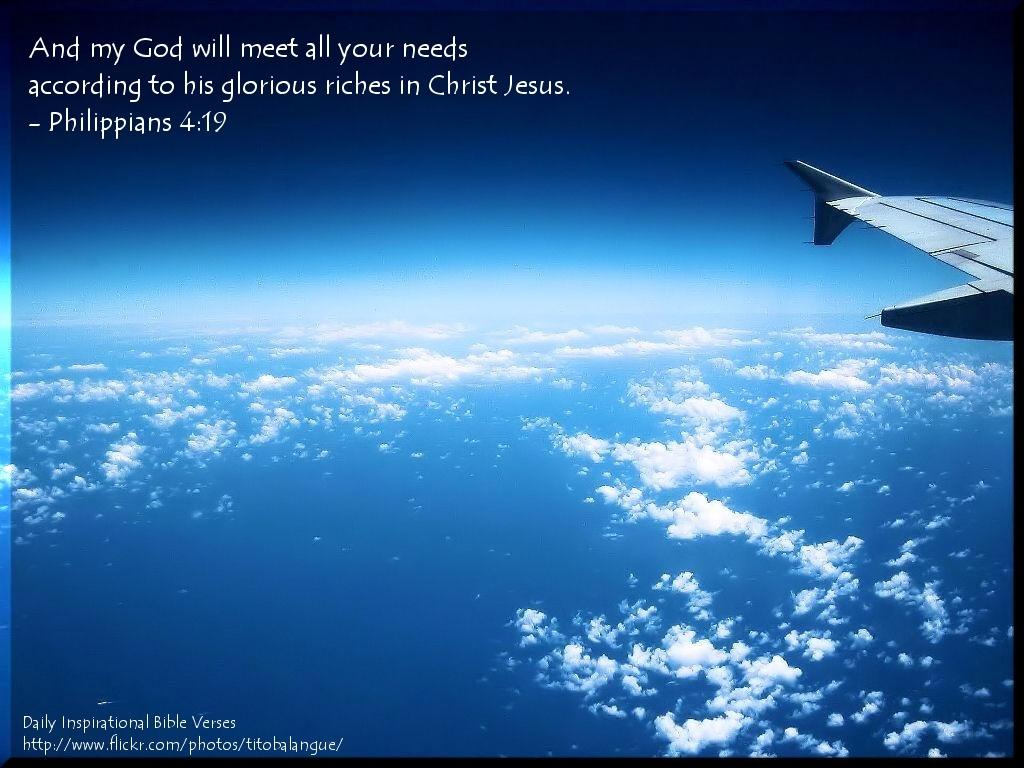<image>
Share a concise interpretation of the image provided. Sign that talks about my god meeting all needs philippians 4:19 